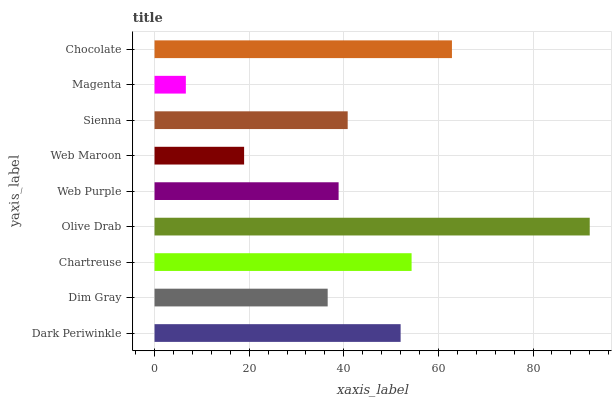Is Magenta the minimum?
Answer yes or no. Yes. Is Olive Drab the maximum?
Answer yes or no. Yes. Is Dim Gray the minimum?
Answer yes or no. No. Is Dim Gray the maximum?
Answer yes or no. No. Is Dark Periwinkle greater than Dim Gray?
Answer yes or no. Yes. Is Dim Gray less than Dark Periwinkle?
Answer yes or no. Yes. Is Dim Gray greater than Dark Periwinkle?
Answer yes or no. No. Is Dark Periwinkle less than Dim Gray?
Answer yes or no. No. Is Sienna the high median?
Answer yes or no. Yes. Is Sienna the low median?
Answer yes or no. Yes. Is Chartreuse the high median?
Answer yes or no. No. Is Magenta the low median?
Answer yes or no. No. 